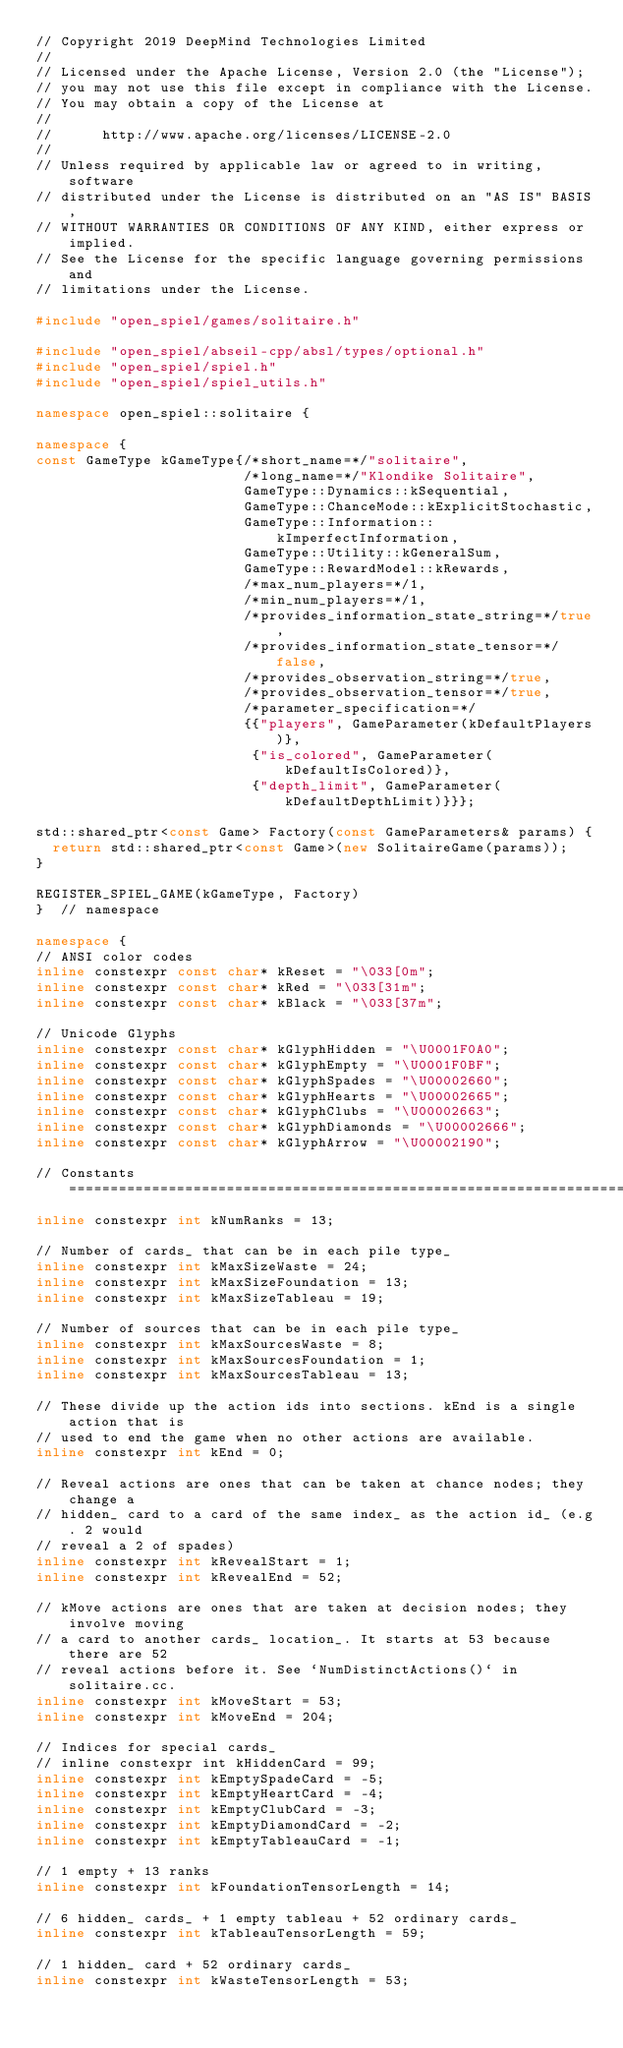Convert code to text. <code><loc_0><loc_0><loc_500><loc_500><_C++_>// Copyright 2019 DeepMind Technologies Limited
//
// Licensed under the Apache License, Version 2.0 (the "License");
// you may not use this file except in compliance with the License.
// You may obtain a copy of the License at
//
//      http://www.apache.org/licenses/LICENSE-2.0
//
// Unless required by applicable law or agreed to in writing, software
// distributed under the License is distributed on an "AS IS" BASIS,
// WITHOUT WARRANTIES OR CONDITIONS OF ANY KIND, either express or implied.
// See the License for the specific language governing permissions and
// limitations under the License.

#include "open_spiel/games/solitaire.h"

#include "open_spiel/abseil-cpp/absl/types/optional.h"
#include "open_spiel/spiel.h"
#include "open_spiel/spiel_utils.h"

namespace open_spiel::solitaire {

namespace {
const GameType kGameType{/*short_name=*/"solitaire",
                         /*long_name=*/"Klondike Solitaire",
                         GameType::Dynamics::kSequential,
                         GameType::ChanceMode::kExplicitStochastic,
                         GameType::Information::kImperfectInformation,
                         GameType::Utility::kGeneralSum,
                         GameType::RewardModel::kRewards,
                         /*max_num_players=*/1,
                         /*min_num_players=*/1,
                         /*provides_information_state_string=*/true,
                         /*provides_information_state_tensor=*/false,
                         /*provides_observation_string=*/true,
                         /*provides_observation_tensor=*/true,
                         /*parameter_specification=*/
                         {{"players", GameParameter(kDefaultPlayers)},
                          {"is_colored", GameParameter(kDefaultIsColored)},
                          {"depth_limit", GameParameter(kDefaultDepthLimit)}}};

std::shared_ptr<const Game> Factory(const GameParameters& params) {
  return std::shared_ptr<const Game>(new SolitaireGame(params));
}

REGISTER_SPIEL_GAME(kGameType, Factory)
}  // namespace

namespace {
// ANSI color codes
inline constexpr const char* kReset = "\033[0m";
inline constexpr const char* kRed = "\033[31m";
inline constexpr const char* kBlack = "\033[37m";

// Unicode Glyphs
inline constexpr const char* kGlyphHidden = "\U0001F0A0";
inline constexpr const char* kGlyphEmpty = "\U0001F0BF";
inline constexpr const char* kGlyphSpades = "\U00002660";
inline constexpr const char* kGlyphHearts = "\U00002665";
inline constexpr const char* kGlyphClubs = "\U00002663";
inline constexpr const char* kGlyphDiamonds = "\U00002666";
inline constexpr const char* kGlyphArrow = "\U00002190";

// Constants ===================================================================
inline constexpr int kNumRanks = 13;

// Number of cards_ that can be in each pile type_
inline constexpr int kMaxSizeWaste = 24;
inline constexpr int kMaxSizeFoundation = 13;
inline constexpr int kMaxSizeTableau = 19;

// Number of sources that can be in each pile type_
inline constexpr int kMaxSourcesWaste = 8;
inline constexpr int kMaxSourcesFoundation = 1;
inline constexpr int kMaxSourcesTableau = 13;

// These divide up the action ids into sections. kEnd is a single action that is
// used to end the game when no other actions are available.
inline constexpr int kEnd = 0;

// Reveal actions are ones that can be taken at chance nodes; they change a
// hidden_ card to a card of the same index_ as the action id_ (e.g. 2 would
// reveal a 2 of spades)
inline constexpr int kRevealStart = 1;
inline constexpr int kRevealEnd = 52;

// kMove actions are ones that are taken at decision nodes; they involve moving
// a card to another cards_ location_. It starts at 53 because there are 52
// reveal actions before it. See `NumDistinctActions()` in solitaire.cc.
inline constexpr int kMoveStart = 53;
inline constexpr int kMoveEnd = 204;

// Indices for special cards_
// inline constexpr int kHiddenCard = 99;
inline constexpr int kEmptySpadeCard = -5;
inline constexpr int kEmptyHeartCard = -4;
inline constexpr int kEmptyClubCard = -3;
inline constexpr int kEmptyDiamondCard = -2;
inline constexpr int kEmptyTableauCard = -1;

// 1 empty + 13 ranks
inline constexpr int kFoundationTensorLength = 14;

// 6 hidden_ cards_ + 1 empty tableau + 52 ordinary cards_
inline constexpr int kTableauTensorLength = 59;

// 1 hidden_ card + 52 ordinary cards_
inline constexpr int kWasteTensorLength = 53;
</code> 